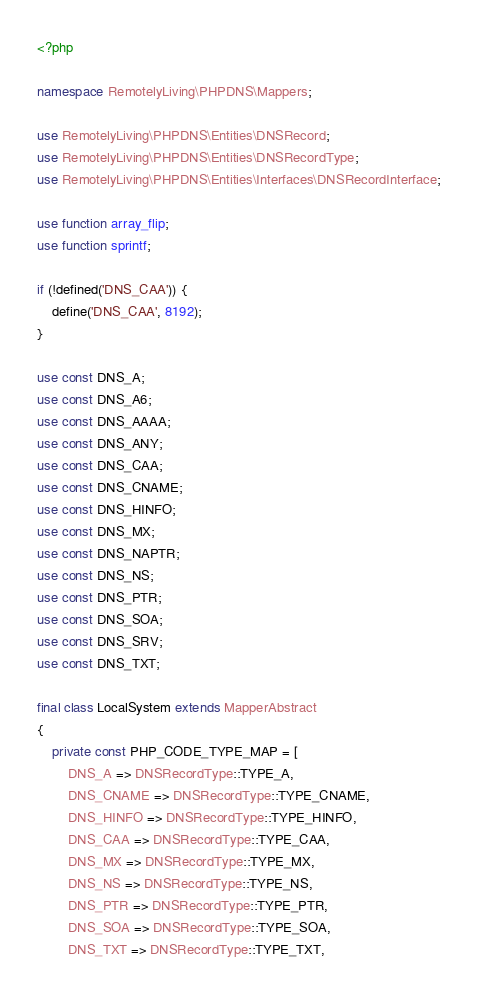<code> <loc_0><loc_0><loc_500><loc_500><_PHP_><?php

namespace RemotelyLiving\PHPDNS\Mappers;

use RemotelyLiving\PHPDNS\Entities\DNSRecord;
use RemotelyLiving\PHPDNS\Entities\DNSRecordType;
use RemotelyLiving\PHPDNS\Entities\Interfaces\DNSRecordInterface;

use function array_flip;
use function sprintf;

if (!defined('DNS_CAA')) {
    define('DNS_CAA', 8192);
}

use const DNS_A;
use const DNS_A6;
use const DNS_AAAA;
use const DNS_ANY;
use const DNS_CAA;
use const DNS_CNAME;
use const DNS_HINFO;
use const DNS_MX;
use const DNS_NAPTR;
use const DNS_NS;
use const DNS_PTR;
use const DNS_SOA;
use const DNS_SRV;
use const DNS_TXT;

final class LocalSystem extends MapperAbstract
{
    private const PHP_CODE_TYPE_MAP = [
        DNS_A => DNSRecordType::TYPE_A,
        DNS_CNAME => DNSRecordType::TYPE_CNAME,
        DNS_HINFO => DNSRecordType::TYPE_HINFO,
        DNS_CAA => DNSRecordType::TYPE_CAA,
        DNS_MX => DNSRecordType::TYPE_MX,
        DNS_NS => DNSRecordType::TYPE_NS,
        DNS_PTR => DNSRecordType::TYPE_PTR,
        DNS_SOA => DNSRecordType::TYPE_SOA,
        DNS_TXT => DNSRecordType::TYPE_TXT,</code> 